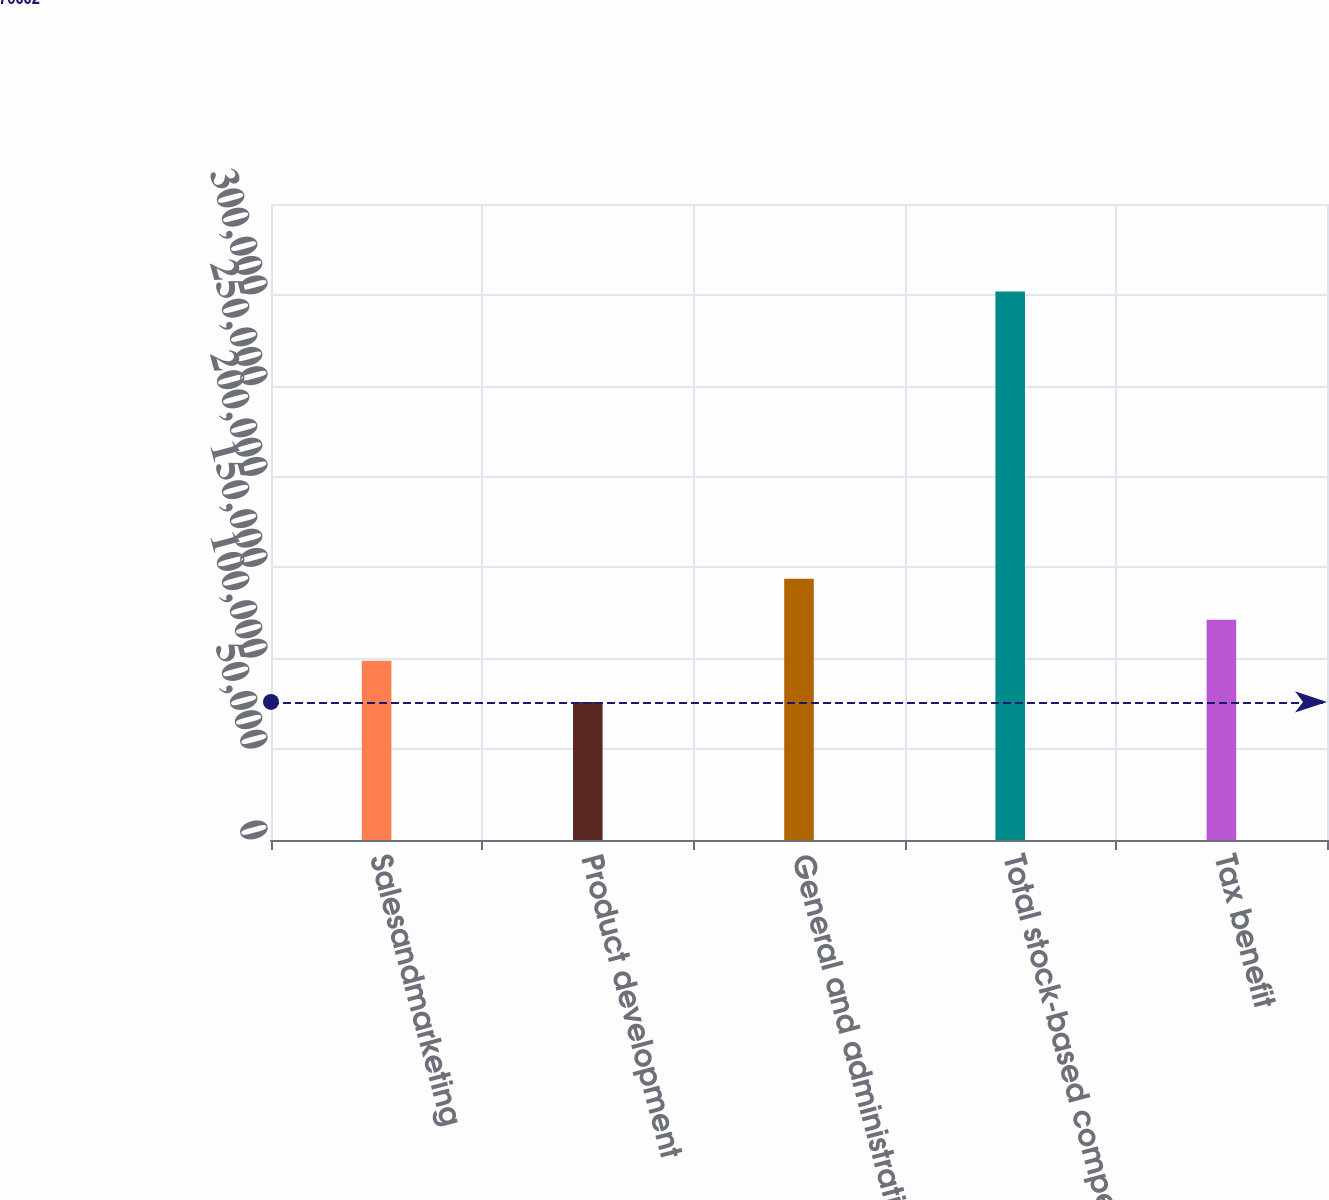<chart> <loc_0><loc_0><loc_500><loc_500><bar_chart><fcel>Salesandmarketing<fcel>Product development<fcel>General and administrative<fcel>Total stock-based compensation<fcel>Tax benefit<nl><fcel>98583.1<fcel>76002<fcel>143745<fcel>301813<fcel>121164<nl></chart> 